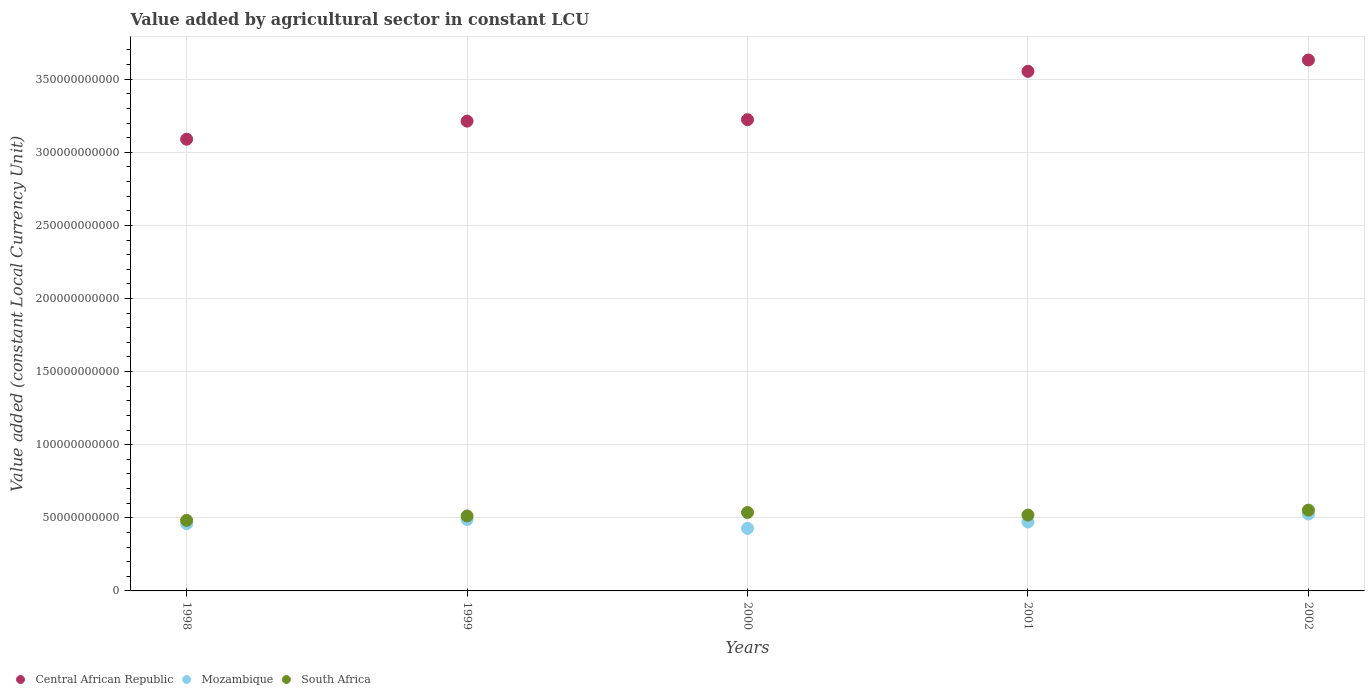What is the value added by agricultural sector in Mozambique in 2002?
Keep it short and to the point. 5.26e+1. Across all years, what is the maximum value added by agricultural sector in South Africa?
Your response must be concise. 5.53e+1. Across all years, what is the minimum value added by agricultural sector in South Africa?
Your response must be concise. 4.83e+1. In which year was the value added by agricultural sector in South Africa maximum?
Your answer should be very brief. 2002. What is the total value added by agricultural sector in Mozambique in the graph?
Your answer should be compact. 2.37e+11. What is the difference between the value added by agricultural sector in Mozambique in 1999 and that in 2002?
Make the answer very short. -3.74e+09. What is the difference between the value added by agricultural sector in Mozambique in 1999 and the value added by agricultural sector in Central African Republic in 2001?
Keep it short and to the point. -3.07e+11. What is the average value added by agricultural sector in Mozambique per year?
Provide a short and direct response. 4.75e+1. In the year 1998, what is the difference between the value added by agricultural sector in Central African Republic and value added by agricultural sector in South Africa?
Ensure brevity in your answer.  2.61e+11. What is the ratio of the value added by agricultural sector in South Africa in 1999 to that in 2001?
Make the answer very short. 0.99. Is the value added by agricultural sector in Central African Republic in 2001 less than that in 2002?
Make the answer very short. Yes. Is the difference between the value added by agricultural sector in Central African Republic in 1999 and 2002 greater than the difference between the value added by agricultural sector in South Africa in 1999 and 2002?
Make the answer very short. No. What is the difference between the highest and the second highest value added by agricultural sector in Mozambique?
Make the answer very short. 3.74e+09. What is the difference between the highest and the lowest value added by agricultural sector in Central African Republic?
Provide a short and direct response. 5.42e+1. Is the sum of the value added by agricultural sector in South Africa in 2000 and 2001 greater than the maximum value added by agricultural sector in Mozambique across all years?
Ensure brevity in your answer.  Yes. Is it the case that in every year, the sum of the value added by agricultural sector in Mozambique and value added by agricultural sector in South Africa  is greater than the value added by agricultural sector in Central African Republic?
Make the answer very short. No. Is the value added by agricultural sector in Mozambique strictly greater than the value added by agricultural sector in Central African Republic over the years?
Offer a terse response. No. Is the value added by agricultural sector in Central African Republic strictly less than the value added by agricultural sector in Mozambique over the years?
Your response must be concise. No. How many years are there in the graph?
Provide a succinct answer. 5. What is the difference between two consecutive major ticks on the Y-axis?
Provide a succinct answer. 5.00e+1. Does the graph contain grids?
Provide a succinct answer. Yes. Where does the legend appear in the graph?
Give a very brief answer. Bottom left. What is the title of the graph?
Your answer should be compact. Value added by agricultural sector in constant LCU. Does "Finland" appear as one of the legend labels in the graph?
Your answer should be very brief. No. What is the label or title of the Y-axis?
Your answer should be very brief. Value added (constant Local Currency Unit). What is the Value added (constant Local Currency Unit) in Central African Republic in 1998?
Ensure brevity in your answer.  3.09e+11. What is the Value added (constant Local Currency Unit) in Mozambique in 1998?
Offer a very short reply. 4.60e+1. What is the Value added (constant Local Currency Unit) of South Africa in 1998?
Your response must be concise. 4.83e+1. What is the Value added (constant Local Currency Unit) in Central African Republic in 1999?
Keep it short and to the point. 3.21e+11. What is the Value added (constant Local Currency Unit) in Mozambique in 1999?
Provide a short and direct response. 4.88e+1. What is the Value added (constant Local Currency Unit) in South Africa in 1999?
Provide a short and direct response. 5.13e+1. What is the Value added (constant Local Currency Unit) in Central African Republic in 2000?
Provide a short and direct response. 3.22e+11. What is the Value added (constant Local Currency Unit) of Mozambique in 2000?
Ensure brevity in your answer.  4.28e+1. What is the Value added (constant Local Currency Unit) of South Africa in 2000?
Provide a short and direct response. 5.37e+1. What is the Value added (constant Local Currency Unit) of Central African Republic in 2001?
Your response must be concise. 3.55e+11. What is the Value added (constant Local Currency Unit) of Mozambique in 2001?
Give a very brief answer. 4.71e+1. What is the Value added (constant Local Currency Unit) in South Africa in 2001?
Your response must be concise. 5.19e+1. What is the Value added (constant Local Currency Unit) in Central African Republic in 2002?
Your answer should be very brief. 3.63e+11. What is the Value added (constant Local Currency Unit) in Mozambique in 2002?
Make the answer very short. 5.26e+1. What is the Value added (constant Local Currency Unit) in South Africa in 2002?
Ensure brevity in your answer.  5.53e+1. Across all years, what is the maximum Value added (constant Local Currency Unit) in Central African Republic?
Make the answer very short. 3.63e+11. Across all years, what is the maximum Value added (constant Local Currency Unit) of Mozambique?
Offer a terse response. 5.26e+1. Across all years, what is the maximum Value added (constant Local Currency Unit) of South Africa?
Make the answer very short. 5.53e+1. Across all years, what is the minimum Value added (constant Local Currency Unit) in Central African Republic?
Give a very brief answer. 3.09e+11. Across all years, what is the minimum Value added (constant Local Currency Unit) of Mozambique?
Provide a short and direct response. 4.28e+1. Across all years, what is the minimum Value added (constant Local Currency Unit) of South Africa?
Your answer should be compact. 4.83e+1. What is the total Value added (constant Local Currency Unit) in Central African Republic in the graph?
Keep it short and to the point. 1.67e+12. What is the total Value added (constant Local Currency Unit) in Mozambique in the graph?
Provide a succinct answer. 2.37e+11. What is the total Value added (constant Local Currency Unit) of South Africa in the graph?
Offer a terse response. 2.60e+11. What is the difference between the Value added (constant Local Currency Unit) of Central African Republic in 1998 and that in 1999?
Offer a terse response. -1.24e+1. What is the difference between the Value added (constant Local Currency Unit) in Mozambique in 1998 and that in 1999?
Offer a terse response. -2.82e+09. What is the difference between the Value added (constant Local Currency Unit) in South Africa in 1998 and that in 1999?
Provide a succinct answer. -2.99e+09. What is the difference between the Value added (constant Local Currency Unit) of Central African Republic in 1998 and that in 2000?
Your answer should be very brief. -1.34e+1. What is the difference between the Value added (constant Local Currency Unit) in Mozambique in 1998 and that in 2000?
Provide a succinct answer. 3.23e+09. What is the difference between the Value added (constant Local Currency Unit) of South Africa in 1998 and that in 2000?
Make the answer very short. -5.40e+09. What is the difference between the Value added (constant Local Currency Unit) of Central African Republic in 1998 and that in 2001?
Your answer should be very brief. -4.64e+1. What is the difference between the Value added (constant Local Currency Unit) of Mozambique in 1998 and that in 2001?
Your answer should be compact. -1.11e+09. What is the difference between the Value added (constant Local Currency Unit) of South Africa in 1998 and that in 2001?
Offer a very short reply. -3.63e+09. What is the difference between the Value added (constant Local Currency Unit) in Central African Republic in 1998 and that in 2002?
Keep it short and to the point. -5.42e+1. What is the difference between the Value added (constant Local Currency Unit) of Mozambique in 1998 and that in 2002?
Offer a very short reply. -6.56e+09. What is the difference between the Value added (constant Local Currency Unit) of South Africa in 1998 and that in 2002?
Keep it short and to the point. -7.00e+09. What is the difference between the Value added (constant Local Currency Unit) in Central African Republic in 1999 and that in 2000?
Offer a very short reply. -9.96e+08. What is the difference between the Value added (constant Local Currency Unit) in Mozambique in 1999 and that in 2000?
Keep it short and to the point. 6.05e+09. What is the difference between the Value added (constant Local Currency Unit) of South Africa in 1999 and that in 2000?
Give a very brief answer. -2.41e+09. What is the difference between the Value added (constant Local Currency Unit) in Central African Republic in 1999 and that in 2001?
Offer a very short reply. -3.41e+1. What is the difference between the Value added (constant Local Currency Unit) in Mozambique in 1999 and that in 2001?
Make the answer very short. 1.71e+09. What is the difference between the Value added (constant Local Currency Unit) of South Africa in 1999 and that in 2001?
Offer a terse response. -6.38e+08. What is the difference between the Value added (constant Local Currency Unit) in Central African Republic in 1999 and that in 2002?
Make the answer very short. -4.18e+1. What is the difference between the Value added (constant Local Currency Unit) in Mozambique in 1999 and that in 2002?
Give a very brief answer. -3.74e+09. What is the difference between the Value added (constant Local Currency Unit) of South Africa in 1999 and that in 2002?
Keep it short and to the point. -4.01e+09. What is the difference between the Value added (constant Local Currency Unit) in Central African Republic in 2000 and that in 2001?
Your response must be concise. -3.31e+1. What is the difference between the Value added (constant Local Currency Unit) of Mozambique in 2000 and that in 2001?
Ensure brevity in your answer.  -4.33e+09. What is the difference between the Value added (constant Local Currency Unit) of South Africa in 2000 and that in 2001?
Give a very brief answer. 1.77e+09. What is the difference between the Value added (constant Local Currency Unit) of Central African Republic in 2000 and that in 2002?
Provide a short and direct response. -4.08e+1. What is the difference between the Value added (constant Local Currency Unit) in Mozambique in 2000 and that in 2002?
Give a very brief answer. -9.79e+09. What is the difference between the Value added (constant Local Currency Unit) of South Africa in 2000 and that in 2002?
Offer a terse response. -1.60e+09. What is the difference between the Value added (constant Local Currency Unit) in Central African Republic in 2001 and that in 2002?
Give a very brief answer. -7.74e+09. What is the difference between the Value added (constant Local Currency Unit) in Mozambique in 2001 and that in 2002?
Your response must be concise. -5.46e+09. What is the difference between the Value added (constant Local Currency Unit) of South Africa in 2001 and that in 2002?
Provide a succinct answer. -3.37e+09. What is the difference between the Value added (constant Local Currency Unit) of Central African Republic in 1998 and the Value added (constant Local Currency Unit) of Mozambique in 1999?
Offer a very short reply. 2.60e+11. What is the difference between the Value added (constant Local Currency Unit) in Central African Republic in 1998 and the Value added (constant Local Currency Unit) in South Africa in 1999?
Provide a succinct answer. 2.58e+11. What is the difference between the Value added (constant Local Currency Unit) in Mozambique in 1998 and the Value added (constant Local Currency Unit) in South Africa in 1999?
Provide a succinct answer. -5.24e+09. What is the difference between the Value added (constant Local Currency Unit) in Central African Republic in 1998 and the Value added (constant Local Currency Unit) in Mozambique in 2000?
Your answer should be compact. 2.66e+11. What is the difference between the Value added (constant Local Currency Unit) in Central African Republic in 1998 and the Value added (constant Local Currency Unit) in South Africa in 2000?
Make the answer very short. 2.55e+11. What is the difference between the Value added (constant Local Currency Unit) of Mozambique in 1998 and the Value added (constant Local Currency Unit) of South Africa in 2000?
Keep it short and to the point. -7.65e+09. What is the difference between the Value added (constant Local Currency Unit) of Central African Republic in 1998 and the Value added (constant Local Currency Unit) of Mozambique in 2001?
Your answer should be very brief. 2.62e+11. What is the difference between the Value added (constant Local Currency Unit) of Central African Republic in 1998 and the Value added (constant Local Currency Unit) of South Africa in 2001?
Your answer should be compact. 2.57e+11. What is the difference between the Value added (constant Local Currency Unit) in Mozambique in 1998 and the Value added (constant Local Currency Unit) in South Africa in 2001?
Give a very brief answer. -5.87e+09. What is the difference between the Value added (constant Local Currency Unit) of Central African Republic in 1998 and the Value added (constant Local Currency Unit) of Mozambique in 2002?
Offer a terse response. 2.56e+11. What is the difference between the Value added (constant Local Currency Unit) in Central African Republic in 1998 and the Value added (constant Local Currency Unit) in South Africa in 2002?
Your answer should be compact. 2.54e+11. What is the difference between the Value added (constant Local Currency Unit) in Mozambique in 1998 and the Value added (constant Local Currency Unit) in South Africa in 2002?
Give a very brief answer. -9.25e+09. What is the difference between the Value added (constant Local Currency Unit) in Central African Republic in 1999 and the Value added (constant Local Currency Unit) in Mozambique in 2000?
Provide a succinct answer. 2.79e+11. What is the difference between the Value added (constant Local Currency Unit) in Central African Republic in 1999 and the Value added (constant Local Currency Unit) in South Africa in 2000?
Provide a succinct answer. 2.68e+11. What is the difference between the Value added (constant Local Currency Unit) of Mozambique in 1999 and the Value added (constant Local Currency Unit) of South Africa in 2000?
Give a very brief answer. -4.82e+09. What is the difference between the Value added (constant Local Currency Unit) in Central African Republic in 1999 and the Value added (constant Local Currency Unit) in Mozambique in 2001?
Give a very brief answer. 2.74e+11. What is the difference between the Value added (constant Local Currency Unit) in Central African Republic in 1999 and the Value added (constant Local Currency Unit) in South Africa in 2001?
Provide a short and direct response. 2.69e+11. What is the difference between the Value added (constant Local Currency Unit) in Mozambique in 1999 and the Value added (constant Local Currency Unit) in South Africa in 2001?
Provide a short and direct response. -3.05e+09. What is the difference between the Value added (constant Local Currency Unit) of Central African Republic in 1999 and the Value added (constant Local Currency Unit) of Mozambique in 2002?
Ensure brevity in your answer.  2.69e+11. What is the difference between the Value added (constant Local Currency Unit) in Central African Republic in 1999 and the Value added (constant Local Currency Unit) in South Africa in 2002?
Offer a terse response. 2.66e+11. What is the difference between the Value added (constant Local Currency Unit) in Mozambique in 1999 and the Value added (constant Local Currency Unit) in South Africa in 2002?
Make the answer very short. -6.43e+09. What is the difference between the Value added (constant Local Currency Unit) of Central African Republic in 2000 and the Value added (constant Local Currency Unit) of Mozambique in 2001?
Provide a succinct answer. 2.75e+11. What is the difference between the Value added (constant Local Currency Unit) of Central African Republic in 2000 and the Value added (constant Local Currency Unit) of South Africa in 2001?
Provide a succinct answer. 2.70e+11. What is the difference between the Value added (constant Local Currency Unit) of Mozambique in 2000 and the Value added (constant Local Currency Unit) of South Africa in 2001?
Your response must be concise. -9.10e+09. What is the difference between the Value added (constant Local Currency Unit) in Central African Republic in 2000 and the Value added (constant Local Currency Unit) in Mozambique in 2002?
Your response must be concise. 2.70e+11. What is the difference between the Value added (constant Local Currency Unit) of Central African Republic in 2000 and the Value added (constant Local Currency Unit) of South Africa in 2002?
Your answer should be very brief. 2.67e+11. What is the difference between the Value added (constant Local Currency Unit) in Mozambique in 2000 and the Value added (constant Local Currency Unit) in South Africa in 2002?
Your answer should be very brief. -1.25e+1. What is the difference between the Value added (constant Local Currency Unit) of Central African Republic in 2001 and the Value added (constant Local Currency Unit) of Mozambique in 2002?
Your answer should be very brief. 3.03e+11. What is the difference between the Value added (constant Local Currency Unit) of Central African Republic in 2001 and the Value added (constant Local Currency Unit) of South Africa in 2002?
Your answer should be compact. 3.00e+11. What is the difference between the Value added (constant Local Currency Unit) in Mozambique in 2001 and the Value added (constant Local Currency Unit) in South Africa in 2002?
Provide a short and direct response. -8.14e+09. What is the average Value added (constant Local Currency Unit) of Central African Republic per year?
Your response must be concise. 3.34e+11. What is the average Value added (constant Local Currency Unit) in Mozambique per year?
Offer a terse response. 4.75e+1. What is the average Value added (constant Local Currency Unit) in South Africa per year?
Offer a very short reply. 5.21e+1. In the year 1998, what is the difference between the Value added (constant Local Currency Unit) in Central African Republic and Value added (constant Local Currency Unit) in Mozambique?
Give a very brief answer. 2.63e+11. In the year 1998, what is the difference between the Value added (constant Local Currency Unit) of Central African Republic and Value added (constant Local Currency Unit) of South Africa?
Provide a succinct answer. 2.61e+11. In the year 1998, what is the difference between the Value added (constant Local Currency Unit) in Mozambique and Value added (constant Local Currency Unit) in South Africa?
Your response must be concise. -2.24e+09. In the year 1999, what is the difference between the Value added (constant Local Currency Unit) in Central African Republic and Value added (constant Local Currency Unit) in Mozambique?
Ensure brevity in your answer.  2.72e+11. In the year 1999, what is the difference between the Value added (constant Local Currency Unit) of Central African Republic and Value added (constant Local Currency Unit) of South Africa?
Keep it short and to the point. 2.70e+11. In the year 1999, what is the difference between the Value added (constant Local Currency Unit) in Mozambique and Value added (constant Local Currency Unit) in South Africa?
Provide a succinct answer. -2.41e+09. In the year 2000, what is the difference between the Value added (constant Local Currency Unit) of Central African Republic and Value added (constant Local Currency Unit) of Mozambique?
Provide a succinct answer. 2.80e+11. In the year 2000, what is the difference between the Value added (constant Local Currency Unit) in Central African Republic and Value added (constant Local Currency Unit) in South Africa?
Provide a succinct answer. 2.69e+11. In the year 2000, what is the difference between the Value added (constant Local Currency Unit) in Mozambique and Value added (constant Local Currency Unit) in South Africa?
Your answer should be very brief. -1.09e+1. In the year 2001, what is the difference between the Value added (constant Local Currency Unit) of Central African Republic and Value added (constant Local Currency Unit) of Mozambique?
Your answer should be compact. 3.08e+11. In the year 2001, what is the difference between the Value added (constant Local Currency Unit) in Central African Republic and Value added (constant Local Currency Unit) in South Africa?
Make the answer very short. 3.03e+11. In the year 2001, what is the difference between the Value added (constant Local Currency Unit) in Mozambique and Value added (constant Local Currency Unit) in South Africa?
Your answer should be very brief. -4.77e+09. In the year 2002, what is the difference between the Value added (constant Local Currency Unit) of Central African Republic and Value added (constant Local Currency Unit) of Mozambique?
Make the answer very short. 3.11e+11. In the year 2002, what is the difference between the Value added (constant Local Currency Unit) of Central African Republic and Value added (constant Local Currency Unit) of South Africa?
Your answer should be very brief. 3.08e+11. In the year 2002, what is the difference between the Value added (constant Local Currency Unit) in Mozambique and Value added (constant Local Currency Unit) in South Africa?
Your response must be concise. -2.68e+09. What is the ratio of the Value added (constant Local Currency Unit) of Central African Republic in 1998 to that in 1999?
Make the answer very short. 0.96. What is the ratio of the Value added (constant Local Currency Unit) in Mozambique in 1998 to that in 1999?
Offer a very short reply. 0.94. What is the ratio of the Value added (constant Local Currency Unit) of South Africa in 1998 to that in 1999?
Provide a short and direct response. 0.94. What is the ratio of the Value added (constant Local Currency Unit) of Central African Republic in 1998 to that in 2000?
Make the answer very short. 0.96. What is the ratio of the Value added (constant Local Currency Unit) in Mozambique in 1998 to that in 2000?
Provide a succinct answer. 1.08. What is the ratio of the Value added (constant Local Currency Unit) in South Africa in 1998 to that in 2000?
Offer a very short reply. 0.9. What is the ratio of the Value added (constant Local Currency Unit) in Central African Republic in 1998 to that in 2001?
Provide a succinct answer. 0.87. What is the ratio of the Value added (constant Local Currency Unit) in Mozambique in 1998 to that in 2001?
Provide a short and direct response. 0.98. What is the ratio of the Value added (constant Local Currency Unit) of South Africa in 1998 to that in 2001?
Offer a very short reply. 0.93. What is the ratio of the Value added (constant Local Currency Unit) in Central African Republic in 1998 to that in 2002?
Provide a succinct answer. 0.85. What is the ratio of the Value added (constant Local Currency Unit) of Mozambique in 1998 to that in 2002?
Ensure brevity in your answer.  0.88. What is the ratio of the Value added (constant Local Currency Unit) in South Africa in 1998 to that in 2002?
Your answer should be very brief. 0.87. What is the ratio of the Value added (constant Local Currency Unit) in Mozambique in 1999 to that in 2000?
Your response must be concise. 1.14. What is the ratio of the Value added (constant Local Currency Unit) in South Africa in 1999 to that in 2000?
Provide a short and direct response. 0.96. What is the ratio of the Value added (constant Local Currency Unit) of Central African Republic in 1999 to that in 2001?
Your answer should be very brief. 0.9. What is the ratio of the Value added (constant Local Currency Unit) in Mozambique in 1999 to that in 2001?
Your answer should be compact. 1.04. What is the ratio of the Value added (constant Local Currency Unit) in South Africa in 1999 to that in 2001?
Give a very brief answer. 0.99. What is the ratio of the Value added (constant Local Currency Unit) of Central African Republic in 1999 to that in 2002?
Provide a succinct answer. 0.88. What is the ratio of the Value added (constant Local Currency Unit) in Mozambique in 1999 to that in 2002?
Provide a succinct answer. 0.93. What is the ratio of the Value added (constant Local Currency Unit) of South Africa in 1999 to that in 2002?
Your answer should be compact. 0.93. What is the ratio of the Value added (constant Local Currency Unit) of Central African Republic in 2000 to that in 2001?
Give a very brief answer. 0.91. What is the ratio of the Value added (constant Local Currency Unit) of Mozambique in 2000 to that in 2001?
Make the answer very short. 0.91. What is the ratio of the Value added (constant Local Currency Unit) of South Africa in 2000 to that in 2001?
Provide a short and direct response. 1.03. What is the ratio of the Value added (constant Local Currency Unit) of Central African Republic in 2000 to that in 2002?
Provide a succinct answer. 0.89. What is the ratio of the Value added (constant Local Currency Unit) of Mozambique in 2000 to that in 2002?
Offer a terse response. 0.81. What is the ratio of the Value added (constant Local Currency Unit) of South Africa in 2000 to that in 2002?
Keep it short and to the point. 0.97. What is the ratio of the Value added (constant Local Currency Unit) in Central African Republic in 2001 to that in 2002?
Give a very brief answer. 0.98. What is the ratio of the Value added (constant Local Currency Unit) of Mozambique in 2001 to that in 2002?
Make the answer very short. 0.9. What is the ratio of the Value added (constant Local Currency Unit) in South Africa in 2001 to that in 2002?
Keep it short and to the point. 0.94. What is the difference between the highest and the second highest Value added (constant Local Currency Unit) in Central African Republic?
Offer a very short reply. 7.74e+09. What is the difference between the highest and the second highest Value added (constant Local Currency Unit) in Mozambique?
Keep it short and to the point. 3.74e+09. What is the difference between the highest and the second highest Value added (constant Local Currency Unit) in South Africa?
Offer a very short reply. 1.60e+09. What is the difference between the highest and the lowest Value added (constant Local Currency Unit) in Central African Republic?
Keep it short and to the point. 5.42e+1. What is the difference between the highest and the lowest Value added (constant Local Currency Unit) in Mozambique?
Make the answer very short. 9.79e+09. What is the difference between the highest and the lowest Value added (constant Local Currency Unit) of South Africa?
Give a very brief answer. 7.00e+09. 